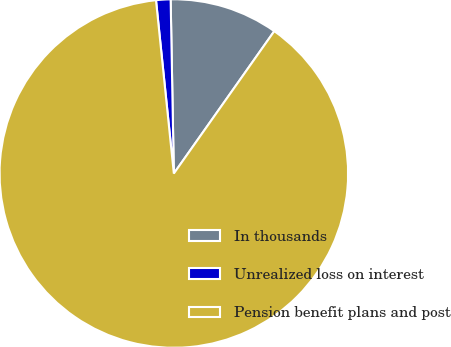<chart> <loc_0><loc_0><loc_500><loc_500><pie_chart><fcel>In thousands<fcel>Unrealized loss on interest<fcel>Pension benefit plans and post<nl><fcel>10.07%<fcel>1.34%<fcel>88.59%<nl></chart> 